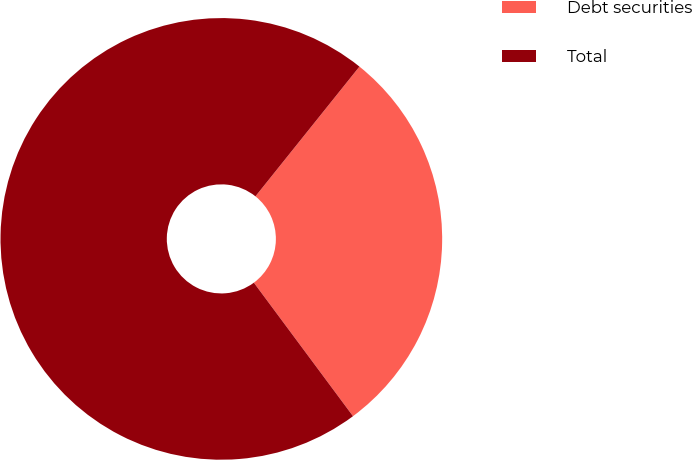Convert chart. <chart><loc_0><loc_0><loc_500><loc_500><pie_chart><fcel>Debt securities<fcel>Total<nl><fcel>29.08%<fcel>70.92%<nl></chart> 